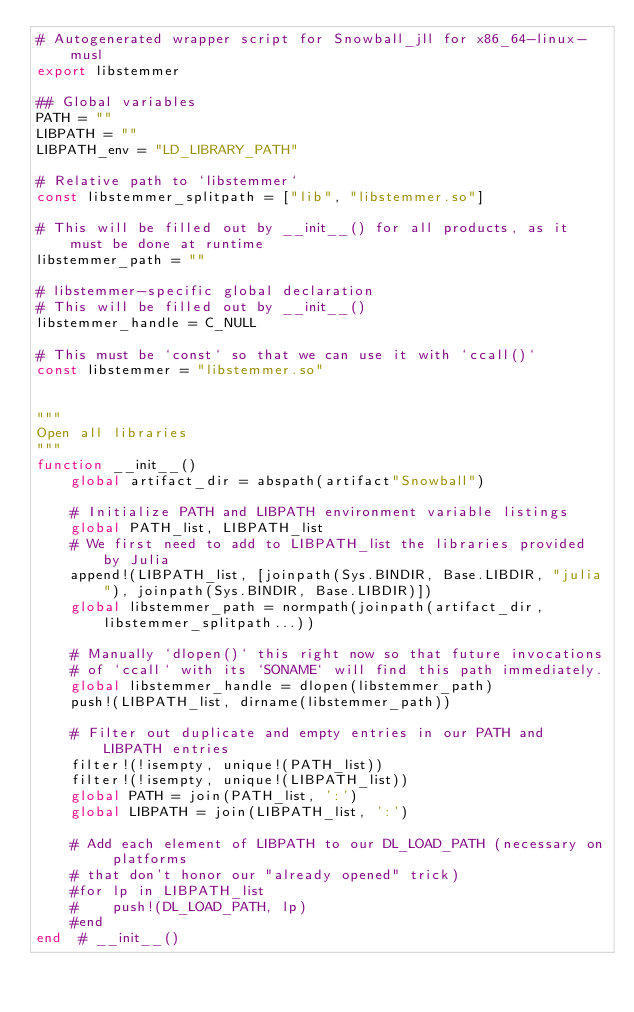Convert code to text. <code><loc_0><loc_0><loc_500><loc_500><_Julia_># Autogenerated wrapper script for Snowball_jll for x86_64-linux-musl
export libstemmer

## Global variables
PATH = ""
LIBPATH = ""
LIBPATH_env = "LD_LIBRARY_PATH"

# Relative path to `libstemmer`
const libstemmer_splitpath = ["lib", "libstemmer.so"]

# This will be filled out by __init__() for all products, as it must be done at runtime
libstemmer_path = ""

# libstemmer-specific global declaration
# This will be filled out by __init__()
libstemmer_handle = C_NULL

# This must be `const` so that we can use it with `ccall()`
const libstemmer = "libstemmer.so"


"""
Open all libraries
"""
function __init__()
    global artifact_dir = abspath(artifact"Snowball")

    # Initialize PATH and LIBPATH environment variable listings
    global PATH_list, LIBPATH_list
    # We first need to add to LIBPATH_list the libraries provided by Julia
    append!(LIBPATH_list, [joinpath(Sys.BINDIR, Base.LIBDIR, "julia"), joinpath(Sys.BINDIR, Base.LIBDIR)])
    global libstemmer_path = normpath(joinpath(artifact_dir, libstemmer_splitpath...))

    # Manually `dlopen()` this right now so that future invocations
    # of `ccall` with its `SONAME` will find this path immediately.
    global libstemmer_handle = dlopen(libstemmer_path)
    push!(LIBPATH_list, dirname(libstemmer_path))

    # Filter out duplicate and empty entries in our PATH and LIBPATH entries
    filter!(!isempty, unique!(PATH_list))
    filter!(!isempty, unique!(LIBPATH_list))
    global PATH = join(PATH_list, ':')
    global LIBPATH = join(LIBPATH_list, ':')

    # Add each element of LIBPATH to our DL_LOAD_PATH (necessary on platforms
    # that don't honor our "already opened" trick)
    #for lp in LIBPATH_list
    #    push!(DL_LOAD_PATH, lp)
    #end
end  # __init__()

</code> 